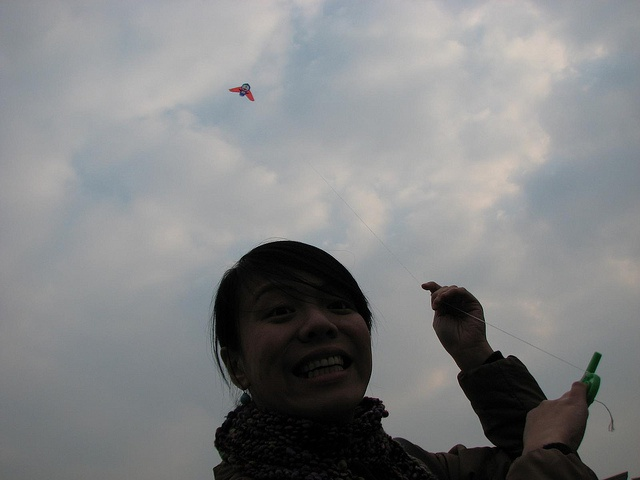Describe the objects in this image and their specific colors. I can see people in gray and black tones and kite in gray, brown, and maroon tones in this image. 